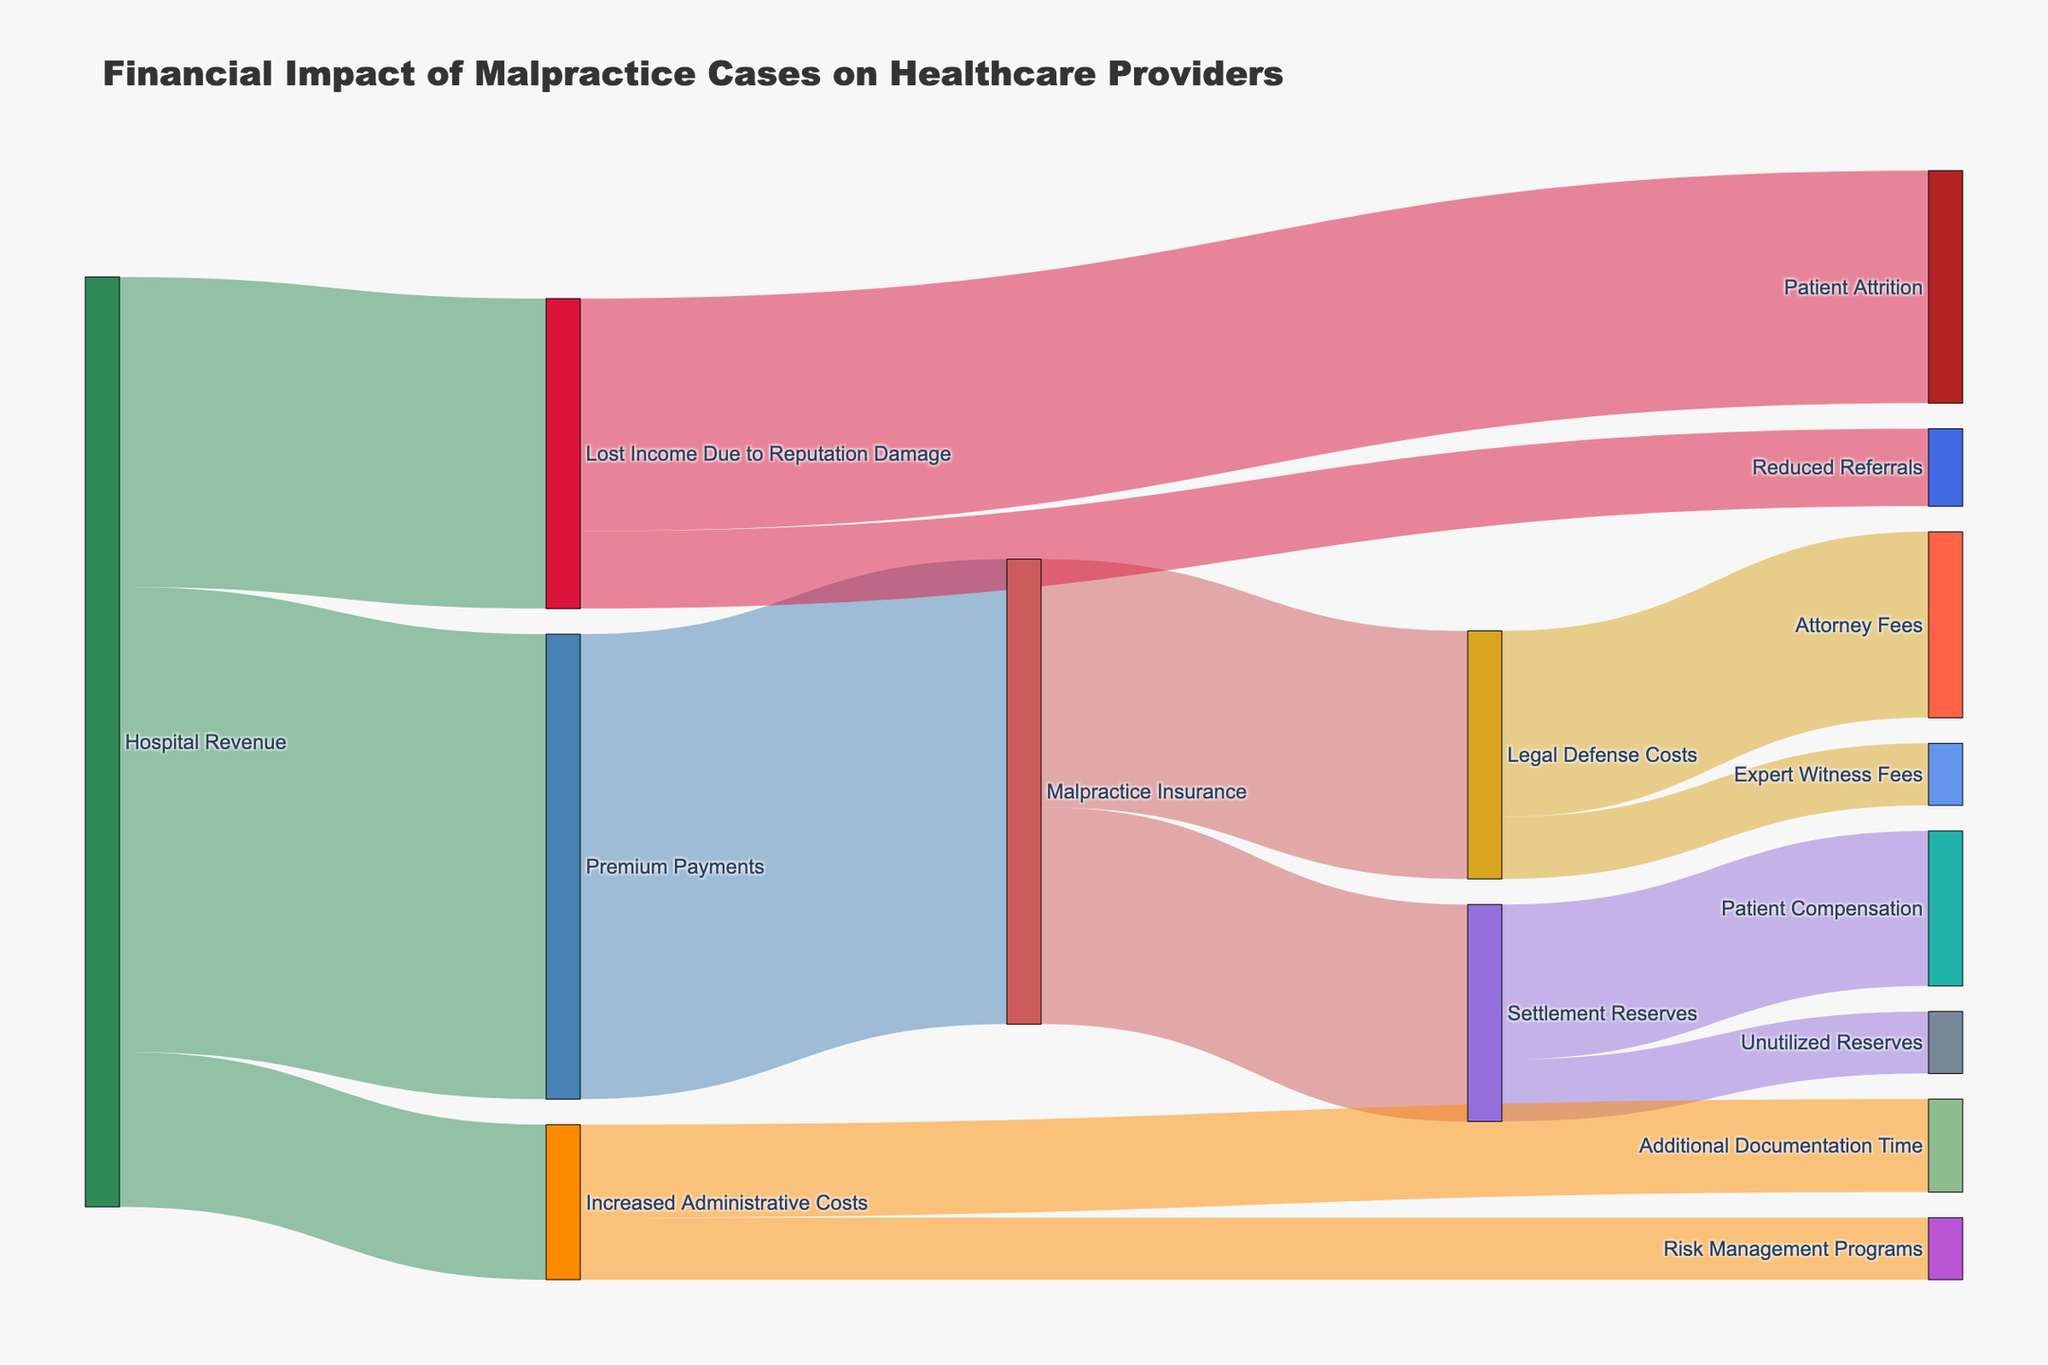How much does the hospital pay in premium payments for malpractice insurance? The diagram shows a flow from 'Premium Payments' to 'Malpractice Insurance' with a value of 150,000.
Answer: 150,000 What is the total cost attributed to legal defense from malpractice claims? There are two flows under 'Legal Defense Costs': 'Attorney Fees' (60,000) and 'Expert Witness Fees' (20,000). Adding them up: 60,000 + 20,000 = 80,000.
Answer: 80,000 What are the total financial consequences of malpractice cases for hospital revenue? Flows from 'Hospital Revenue' are 'Premium Payments' (150,000), 'Lost Income Due to Reputation Damage' (100,000), and 'Increased Administrative Costs' (50,000). Adding them up: 150,000 + 100,000 + 50,000 = 300,000.
Answer: 300,000 Which factor has the highest financial impact under 'Lost Income Due to Reputation Damage'? There are two flows under 'Lost Income Due to Reputation Damage': 'Patient Attrition' (75,000) and 'Reduced Referrals' (25,000). Comparing them, 'Patient Attrition' has the highest value.
Answer: Patient Attrition What is the combined value of reserve funds set aside for settlements? 'Settlement Reserves' splits into 'Patient Compensation' (50,000) and 'Unutilized Reserves' (20,000). Adding them: 50,000 + 20,000 = 70,000.
Answer: 70,000 How much is dedicated to 'Risk Management Programs' stemming from 'Increased Administrative Costs'? The diagram shows a flow from 'Increased Administrative Costs' to 'Risk Management Programs' with a value of 20,000.
Answer: 20,000 What proportion of 'Premium Payments' goes towards 'Legal Defense Costs'? 'Premium Payments' is 150,000, and 'Legal Defense Costs' from 'Malpractice Insurance' is 80,000. The proportion is 80,000 / 150,000 = 0.5333 or 53.33%.
Answer: 53.33% Which outgoing flow from 'Malpractice Insurance' has a higher value: 'Legal Defense Costs' or 'Settlement Reserves'? 'Legal Defense Costs' is 80,000, and 'Settlement Reserves' is 70,000. The higher value is 'Legal Defense Costs'.
Answer: Legal Defense Costs How much more is spent on 'Patient Compensation' compared to 'Unutilized Reserves'? 'Patient Compensation' is 50,000, and 'Unutilized Reserves' is 20,000. The difference is 50,000 - 20,000 = 30,000.
Answer: 30,000 